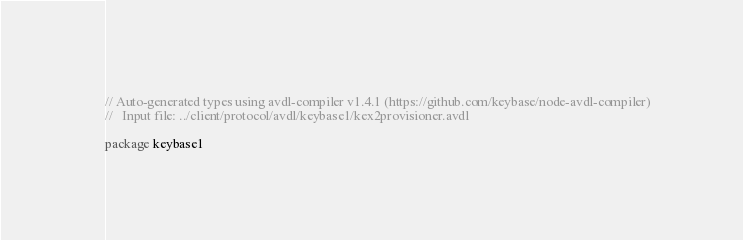<code> <loc_0><loc_0><loc_500><loc_500><_Go_>// Auto-generated types using avdl-compiler v1.4.1 (https://github.com/keybase/node-avdl-compiler)
//   Input file: ../client/protocol/avdl/keybase1/kex2provisioner.avdl

package keybase1
</code> 